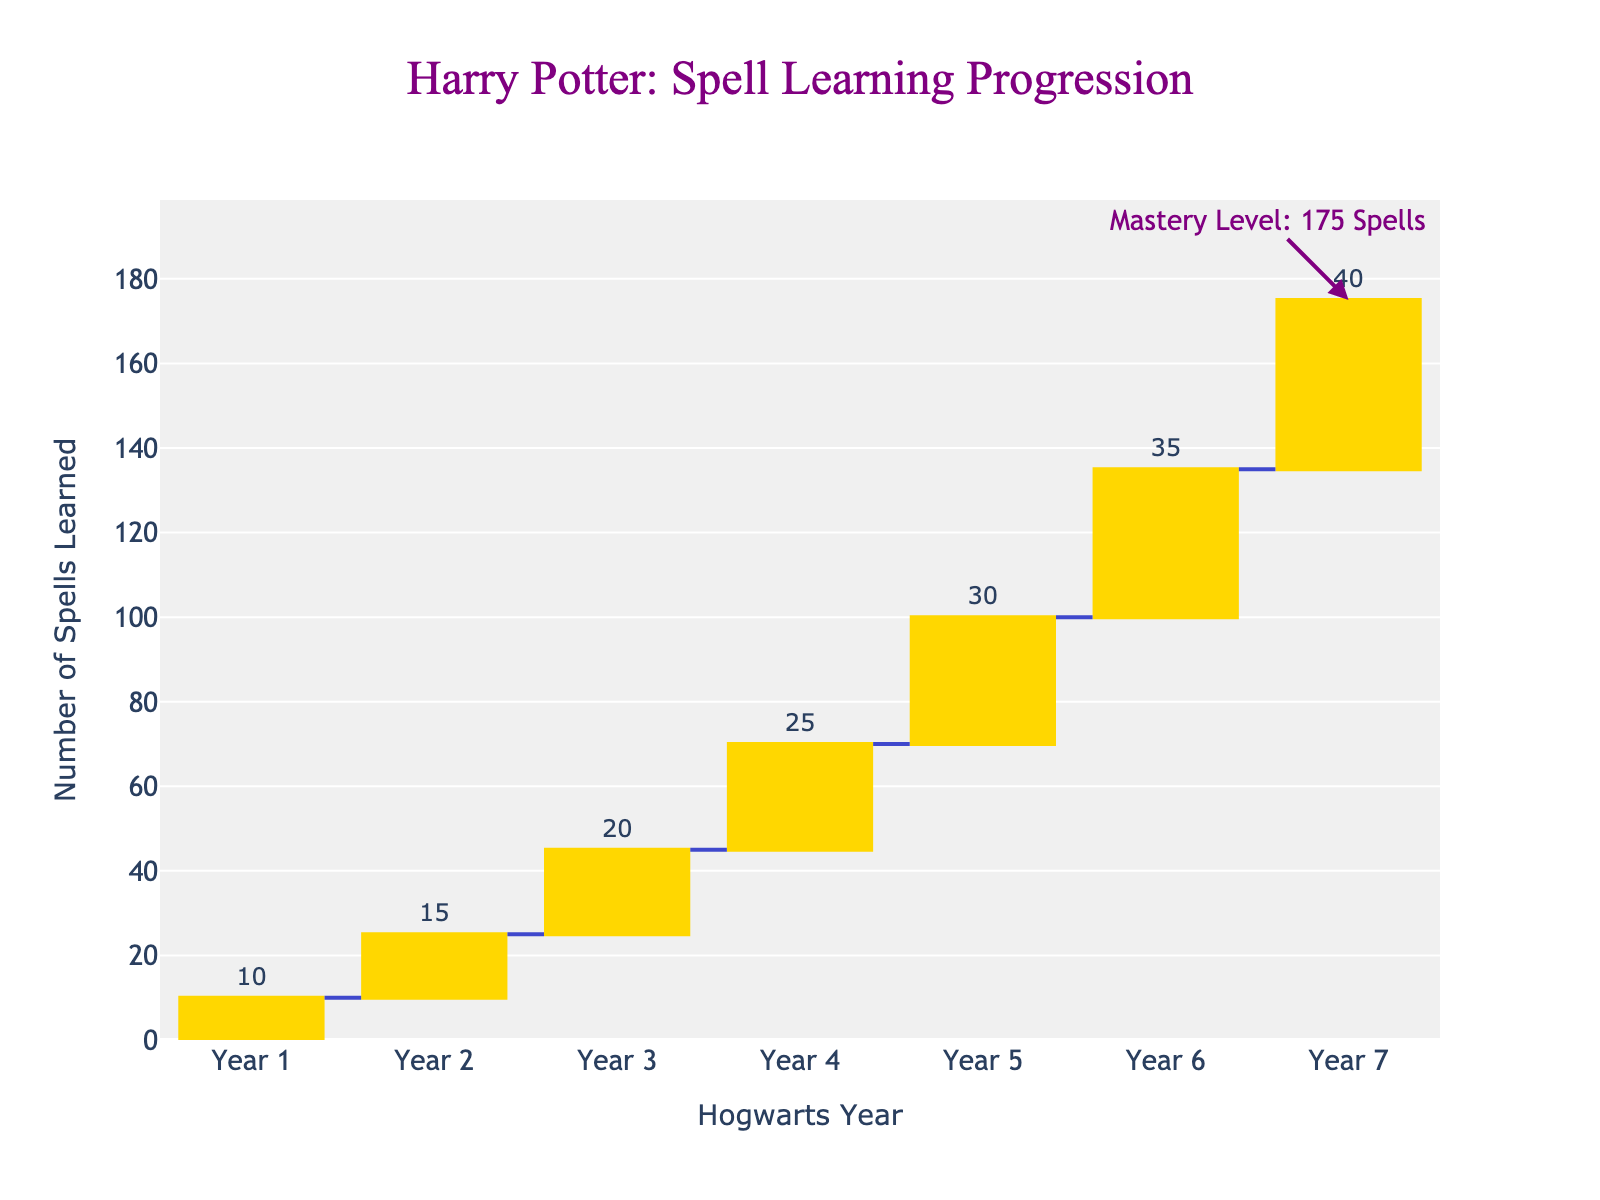what is the title of the figure? The title is displayed at the top center of the chart in a font resembling Harry Potter's style. It reads "Harry Potter: Spell Learning Progression".
Answer: Harry Potter: Spell Learning Progression How many spells were learned in Year 4? Look at the bar above "Year 4" and read the text displayed on top of it, which indicates the number of spells learned that year.
Answer: 25 Which year saw the highest increase in spells learned compared to the previous year? Examine the heights of the bars for each year and compare them to identify which bar is the tallest, indicating the highest increase in spells learned.
Answer: Year 7 What is the cumulative total number of spells learned by the end of Year 5? The cumulative total for each year is displayed at the top of the waterfall chart. Find the value at the top of the Year 5 segment.
Answer: 100 How many more spells were learned in Year 6 compared to Year 3? Identify the spells learned in Year 6 and Year 3 from the text on top of their respective bars. Subtract the spells learned in Year 3 from those learned in Year 6. 35 spells in Year 6 and 20 spells in Year 3, so 35 - 20 = 15.
Answer: 15 What is the average number of spells learned per year over the 7 years? Sum the total number of spells learned across all 7 years and divide by 7. (10 + 15 + 20 + 25 + 30 + 35 + 40 = 175; 175 / 7 = 25)
Answer: 25 Compare the increase in spells learned from Year 1 to Year 2 and Year 2 to Year 3. Which increase is greater? Identify the spells learned in Year 1, Year 2, and Year 3. Calculate the increase from Year 1 to Year 2 (15 - 10 = 5) and from Year 2 to Year 3 (20 - 15 = 5). Both increases are the same.
Answer: Neither, both are equal What is the total number of spells learned between Year 4 and Year 6 inclusive? Sum the spells learned in Year 4, Year 5, and Year 6. (25 + 30 + 35 = 90)
Answer: 90 What annotation is added to the chart, and where is it located? There is an annotation indicating "Mastery Level: 175 Spells" which is placed above the bar for Year 7, pointing towards the cumulative total of 175 spells.
Answer: Mastery Level: 175 Spells What color is used for the connector lines between the bars? The connector lines between the bars are colored in a dark shade which helps to easily trace the cumulative total progression.
Answer: Dark blue 